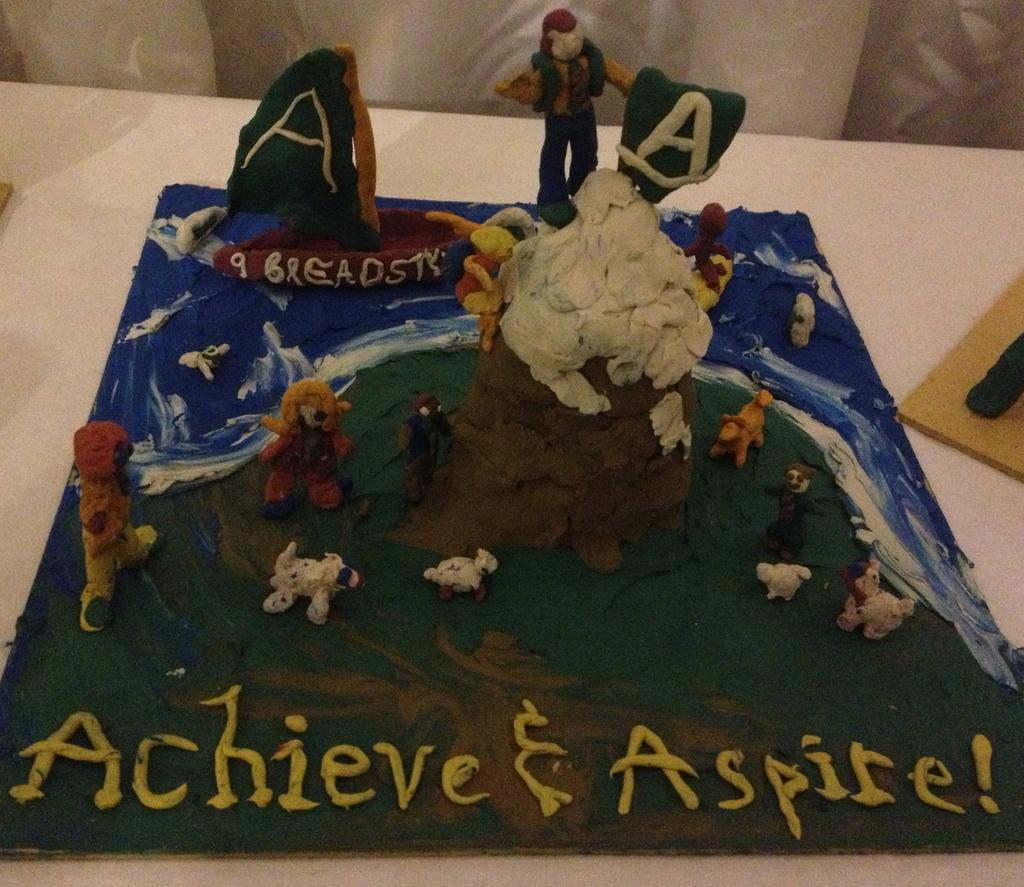What type of art piece is visible in the image? There is a clay art piece in the image. What words are written on the clay art piece? The words "Achieve" and "Aspire" are written on the clay art piece. What type of tent can be seen in the background of the image? There is no tent present in the image; it features a clay art piece with words written on it. 